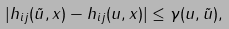<formula> <loc_0><loc_0><loc_500><loc_500>| h _ { i j } ( \tilde { u } , x ) - h _ { i j } ( u , x ) | \leq \gamma ( u , \tilde { u } ) ,</formula> 